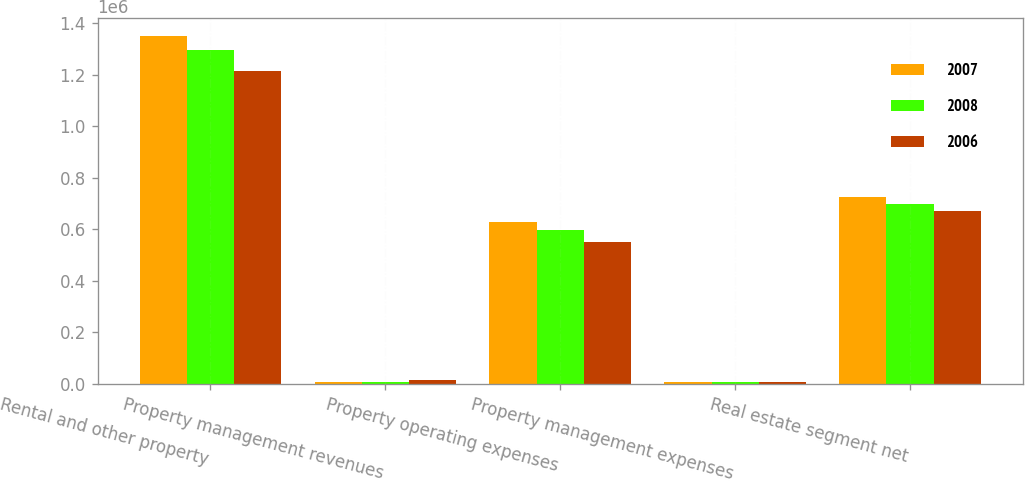<chart> <loc_0><loc_0><loc_500><loc_500><stacked_bar_chart><ecel><fcel>Rental and other property<fcel>Property management revenues<fcel>Property operating expenses<fcel>Property management expenses<fcel>Real estate segment net<nl><fcel>2007<fcel>1.35095e+06<fcel>6345<fcel>626001<fcel>5385<fcel>725909<nl><fcel>2008<fcel>1.29614e+06<fcel>6923<fcel>596902<fcel>6678<fcel>699485<nl><fcel>2006<fcel>1.21296e+06<fcel>12312<fcel>549716<fcel>6289<fcel>669265<nl></chart> 